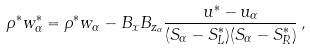Convert formula to latex. <formula><loc_0><loc_0><loc_500><loc_500>\rho ^ { * } w ^ { * } _ { \alpha } = \rho ^ { * } w _ { \alpha } - B _ { x } B _ { z _ { \alpha } } \frac { u ^ { * } - u _ { \alpha } } { ( S _ { \alpha } - S ^ { * } _ { L } ) ( S _ { \alpha } - S ^ { * } _ { R } ) } \, ,</formula> 